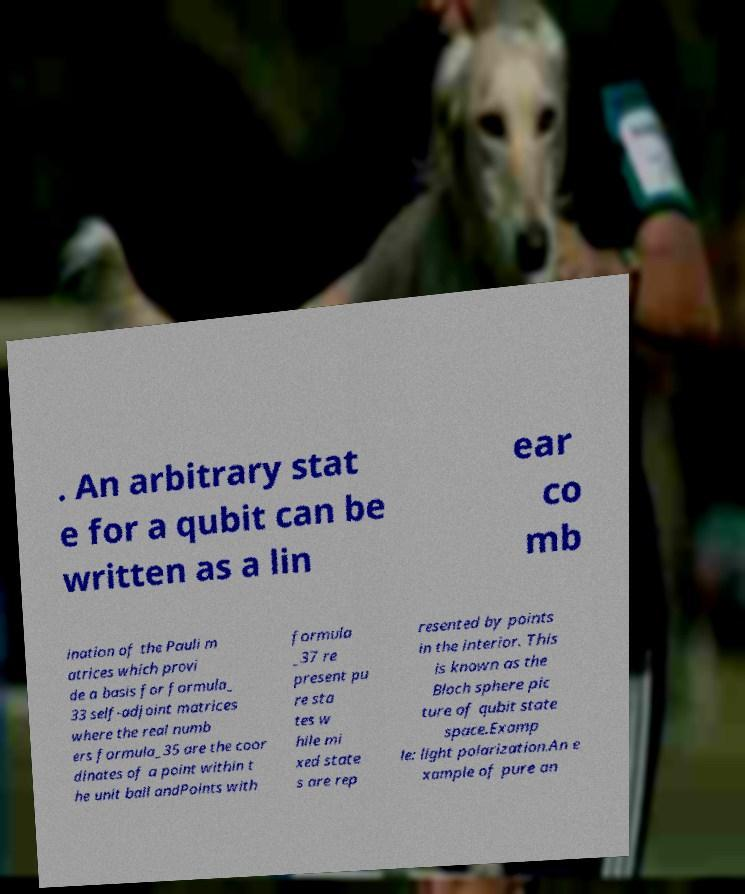Can you read and provide the text displayed in the image?This photo seems to have some interesting text. Can you extract and type it out for me? . An arbitrary stat e for a qubit can be written as a lin ear co mb ination of the Pauli m atrices which provi de a basis for formula_ 33 self-adjoint matrices where the real numb ers formula_35 are the coor dinates of a point within t he unit ball andPoints with formula _37 re present pu re sta tes w hile mi xed state s are rep resented by points in the interior. This is known as the Bloch sphere pic ture of qubit state space.Examp le: light polarization.An e xample of pure an 